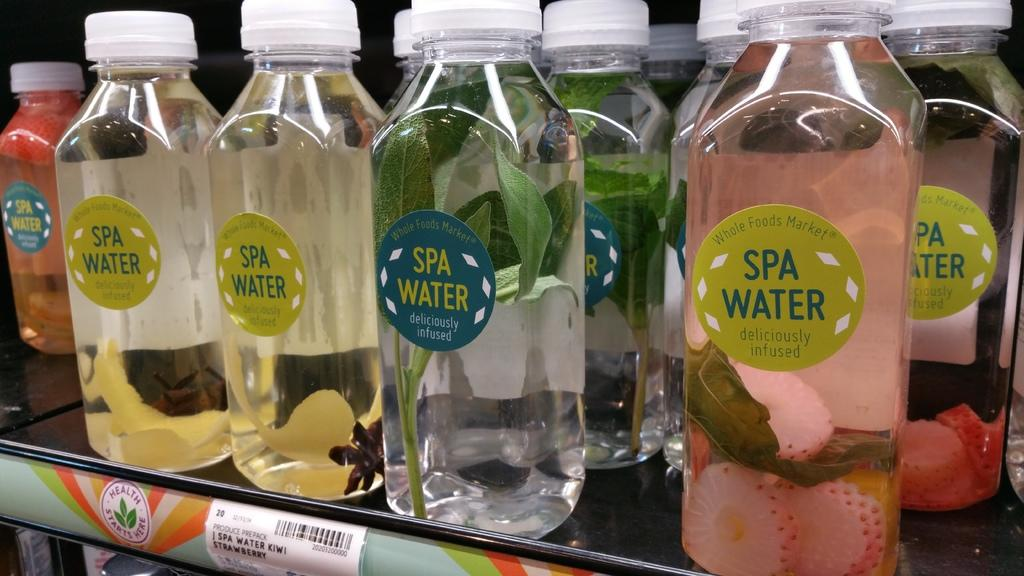<image>
Offer a succinct explanation of the picture presented. Several clear bottles of different types of infused Spa Water with strawberries, lemons, and other herbs in different bottles. 